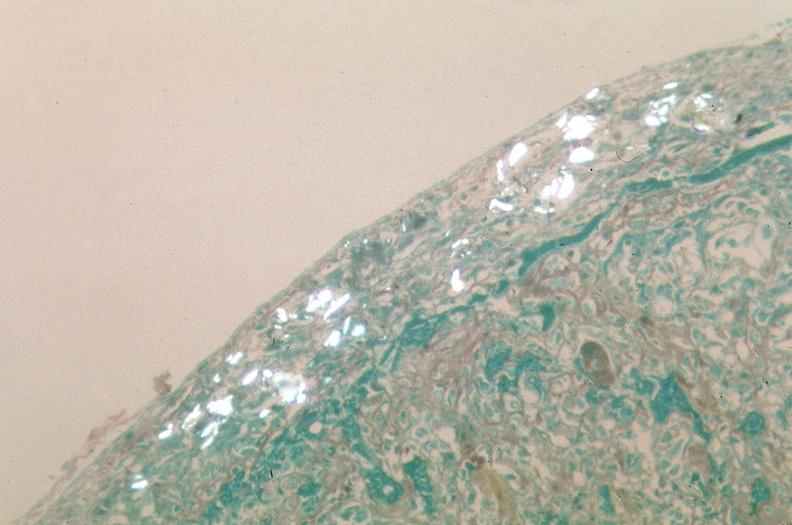does this image show pleura, talc reaction showing talc birefringence?
Answer the question using a single word or phrase. Yes 